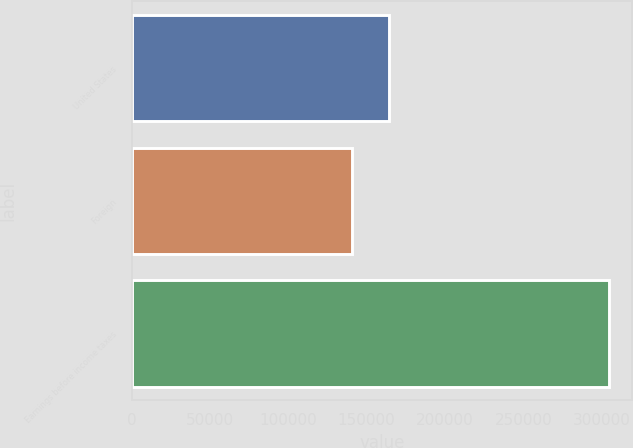Convert chart to OTSL. <chart><loc_0><loc_0><loc_500><loc_500><bar_chart><fcel>United States<fcel>Foreign<fcel>Earnings before income taxes<nl><fcel>164122<fcel>140370<fcel>304492<nl></chart> 